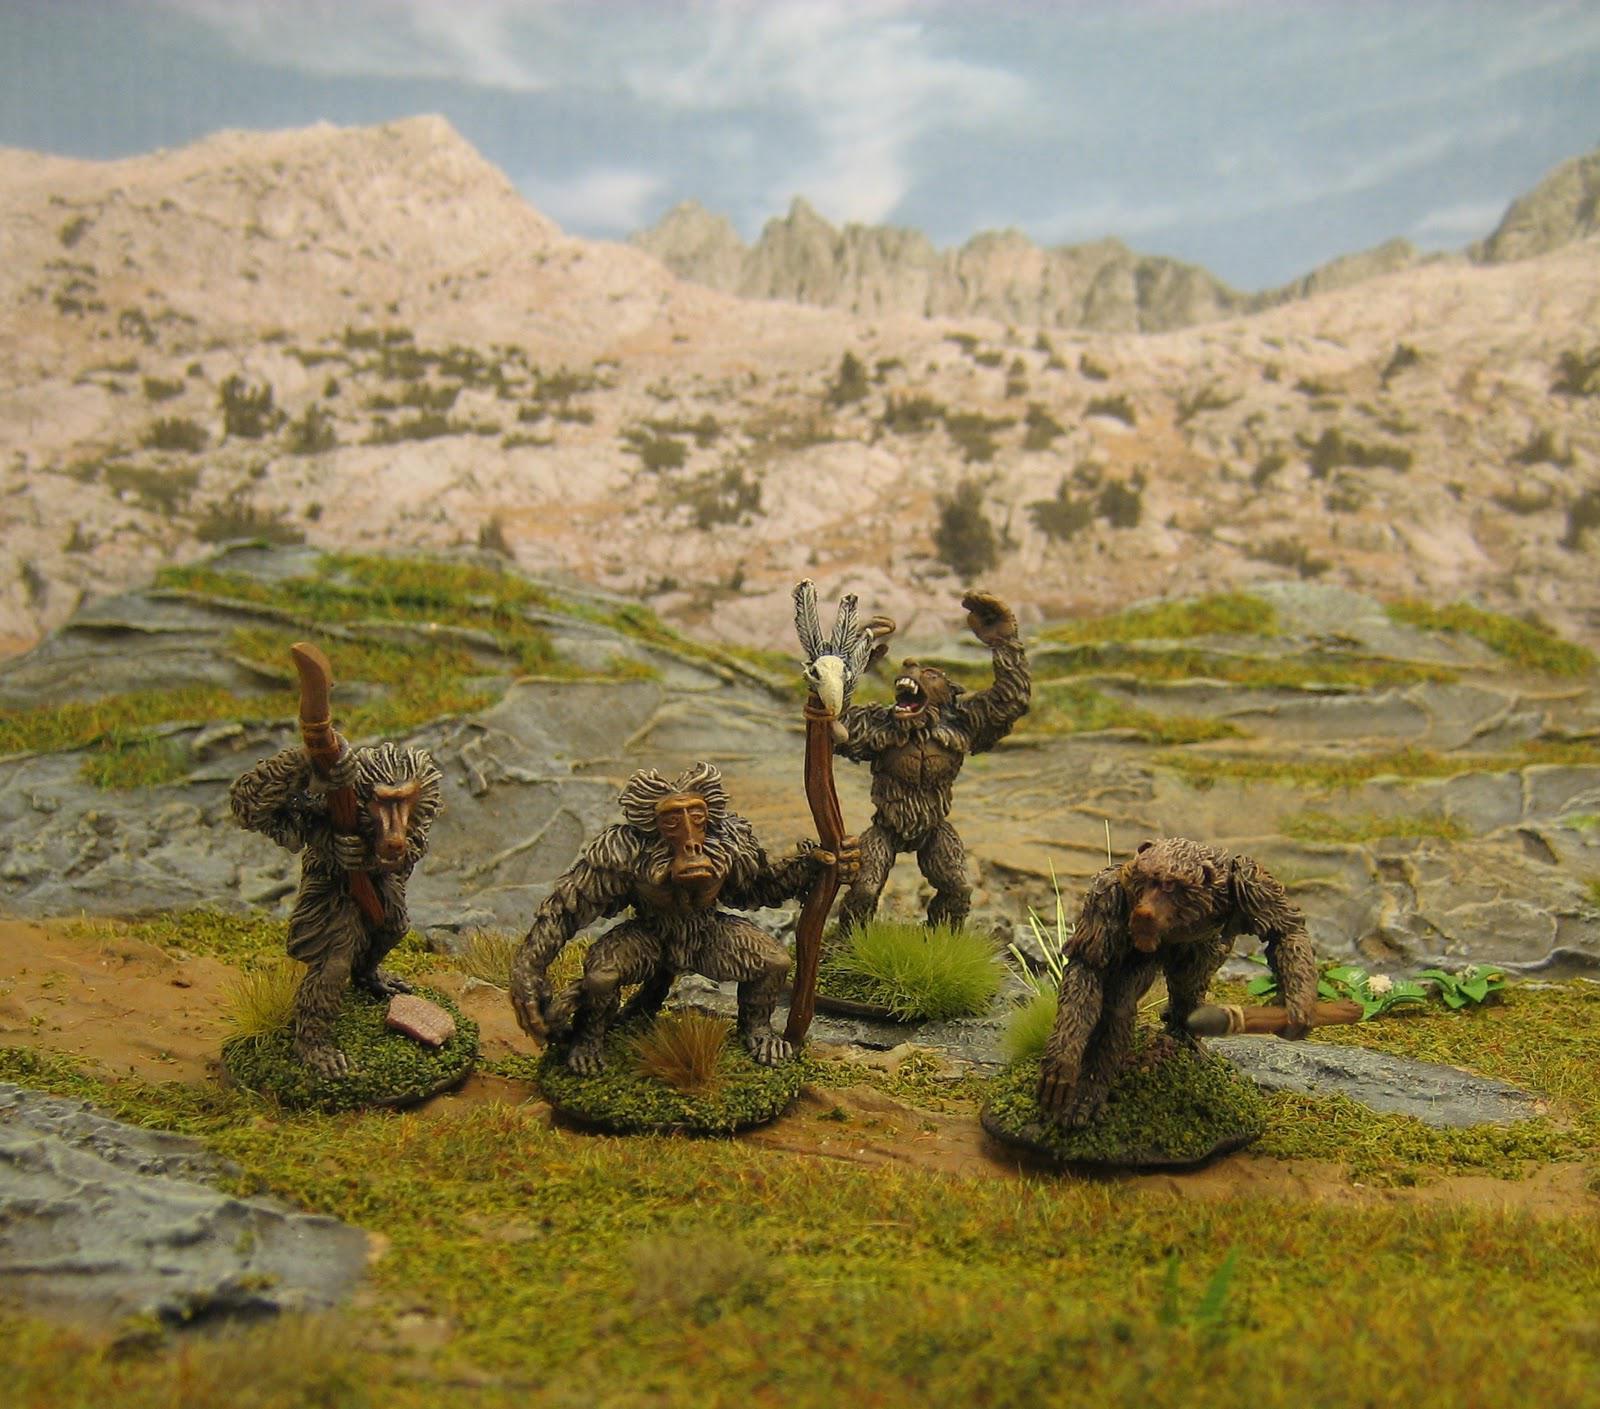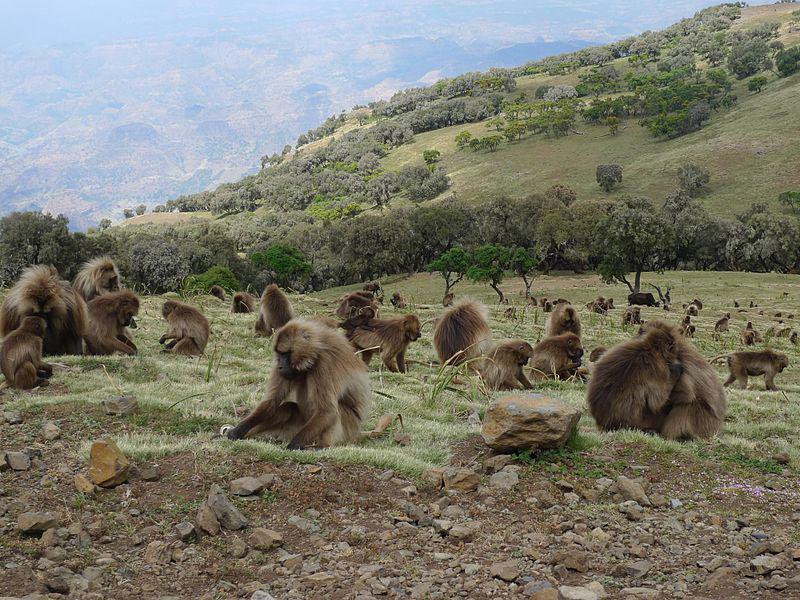The first image is the image on the left, the second image is the image on the right. Considering the images on both sides, is "There are two groups of monkeys in the center of the images." valid? Answer yes or no. No. 